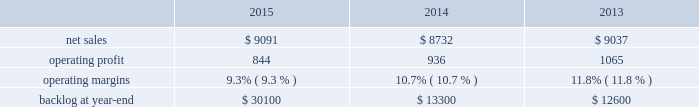$ 15 million for fire control programs due to increased deliveries ( primarily apache ) , partially offset by lower risk retirements ( primarily sniper ae ) .
Adjustments not related to volume , including net profit booking rate adjustments and other matters , were approximately $ 95 million lower for 2014 compared to 2013 .
Backlog backlog increased in 2015 compared to 2014 primarily due to higher orders on pac-3 , lantirn/sniper and certain tactical missile programs , partially offset by lower orders on thaad .
Backlog decreased in 2014 compared to 2013 primarily due to lower orders on thaad and fire control systems programs , partially offset by higher orders on certain tactical missile programs and pac-3 .
Trends we expect mfc 2019s net sales to be flat or experience a slight decline in 2016 as compared to 2015 .
Operating profit is expected to decrease by approximately 20 percent , driven by contract mix and fewer risk retirements in 2016 compared to 2015 .
Accordingly , operating profit margin is expected to decline from 2015 levels .
Mission systems and training as previously described , on november 6 , 2015 , we acquired sikorsky and aligned the sikorsky business under our mst business segment .
The results of the acquired sikorsky business have been included in our financial results from the november 6 , 2015 acquisition date through december 31 , 2015 .
As a result , our consolidated operating results and mst business segment operating results for the year ended december 31 , 2015 do not reflect a full year of sikorsky operations .
Our mst business segment provides design , manufacture , service and support for a variety of military and civil helicopters , ship and submarine mission and combat systems ; mission systems and sensors for rotary and fixed-wing aircraft ; sea and land-based missile defense systems ; radar systems ; the littoral combat ship ( lcs ) ; simulation and training services ; and unmanned systems and technologies .
In addition , mst supports the needs of customers in cybersecurity and delivers communication and command and control capabilities through complex mission solutions for defense applications .
Mst 2019s major programs include black hawk and seahawk helicopters , aegis combat system ( aegis ) , lcs , space fence , advanced hawkeye radar system , and tpq-53 radar system .
Mst 2019s operating results included the following ( in millions ) : .
2015 compared to 2014 mst 2019s net sales in 2015 increased $ 359 million , or 4% ( 4 % ) , compared to 2014 .
The increase was attributable to net sales of approximately $ 400 million from sikorsky , net of adjustments required to account for the acquisition of this business in the fourth quarter of 2015 ; and approximately $ 220 million for integrated warfare systems and sensors programs , primarily due to the ramp-up of recently awarded programs ( space fence ) .
These increases were partially offset by lower net sales of approximately $ 150 million for undersea systems programs due to decreased volume as a result of in-theater force reductions ( primarily persistent threat detection system ) ; and approximately $ 105 million for ship and aviation systems programs primarily due to decreased volume ( merlin capability sustainment program ) .
Mst 2019s operating profit in 2015 decreased $ 92 million , or 10% ( 10 % ) , compared to 2014 .
Operating profit decreased by approximately $ 75 million due to performance matters on an international program ; approximately $ 45 million for sikorsky due primarily to intangible amortization and adjustments required to account for the acquisition of this business in the fourth quarter of 2015 ; and approximately $ 15 million for integrated warfare systems and sensors programs , primarily due to investments made in connection with a recently awarded next generation radar technology program , partially offset by higher risk retirements ( including halifax class modernization ) .
These decreases were partially offset by approximately $ 20 million in increased operating profit for training and logistics services programs , primarily due to reserves recorded on certain programs in 2014 that were not repeated in 2015 .
Adjustments not related to volume , including net profit booking rate adjustments and other matters , were approximately $ 100 million lower in 2015 compared to 2014. .
What were average operating margins for mst in millions from 2013 to 2015? 
Computations: table_average(operating margins, none)
Answer: 0.106. $ 15 million for fire control programs due to increased deliveries ( primarily apache ) , partially offset by lower risk retirements ( primarily sniper ae ) .
Adjustments not related to volume , including net profit booking rate adjustments and other matters , were approximately $ 95 million lower for 2014 compared to 2013 .
Backlog backlog increased in 2015 compared to 2014 primarily due to higher orders on pac-3 , lantirn/sniper and certain tactical missile programs , partially offset by lower orders on thaad .
Backlog decreased in 2014 compared to 2013 primarily due to lower orders on thaad and fire control systems programs , partially offset by higher orders on certain tactical missile programs and pac-3 .
Trends we expect mfc 2019s net sales to be flat or experience a slight decline in 2016 as compared to 2015 .
Operating profit is expected to decrease by approximately 20 percent , driven by contract mix and fewer risk retirements in 2016 compared to 2015 .
Accordingly , operating profit margin is expected to decline from 2015 levels .
Mission systems and training as previously described , on november 6 , 2015 , we acquired sikorsky and aligned the sikorsky business under our mst business segment .
The results of the acquired sikorsky business have been included in our financial results from the november 6 , 2015 acquisition date through december 31 , 2015 .
As a result , our consolidated operating results and mst business segment operating results for the year ended december 31 , 2015 do not reflect a full year of sikorsky operations .
Our mst business segment provides design , manufacture , service and support for a variety of military and civil helicopters , ship and submarine mission and combat systems ; mission systems and sensors for rotary and fixed-wing aircraft ; sea and land-based missile defense systems ; radar systems ; the littoral combat ship ( lcs ) ; simulation and training services ; and unmanned systems and technologies .
In addition , mst supports the needs of customers in cybersecurity and delivers communication and command and control capabilities through complex mission solutions for defense applications .
Mst 2019s major programs include black hawk and seahawk helicopters , aegis combat system ( aegis ) , lcs , space fence , advanced hawkeye radar system , and tpq-53 radar system .
Mst 2019s operating results included the following ( in millions ) : .
2015 compared to 2014 mst 2019s net sales in 2015 increased $ 359 million , or 4% ( 4 % ) , compared to 2014 .
The increase was attributable to net sales of approximately $ 400 million from sikorsky , net of adjustments required to account for the acquisition of this business in the fourth quarter of 2015 ; and approximately $ 220 million for integrated warfare systems and sensors programs , primarily due to the ramp-up of recently awarded programs ( space fence ) .
These increases were partially offset by lower net sales of approximately $ 150 million for undersea systems programs due to decreased volume as a result of in-theater force reductions ( primarily persistent threat detection system ) ; and approximately $ 105 million for ship and aviation systems programs primarily due to decreased volume ( merlin capability sustainment program ) .
Mst 2019s operating profit in 2015 decreased $ 92 million , or 10% ( 10 % ) , compared to 2014 .
Operating profit decreased by approximately $ 75 million due to performance matters on an international program ; approximately $ 45 million for sikorsky due primarily to intangible amortization and adjustments required to account for the acquisition of this business in the fourth quarter of 2015 ; and approximately $ 15 million for integrated warfare systems and sensors programs , primarily due to investments made in connection with a recently awarded next generation radar technology program , partially offset by higher risk retirements ( including halifax class modernization ) .
These decreases were partially offset by approximately $ 20 million in increased operating profit for training and logistics services programs , primarily due to reserves recorded on certain programs in 2014 that were not repeated in 2015 .
Adjustments not related to volume , including net profit booking rate adjustments and other matters , were approximately $ 100 million lower in 2015 compared to 2014. .
What was the percent of the total decline in mst 2019s operating profit in 2015 associated with performance matters? 
Computations: (75 / 92)
Answer: 0.81522. 